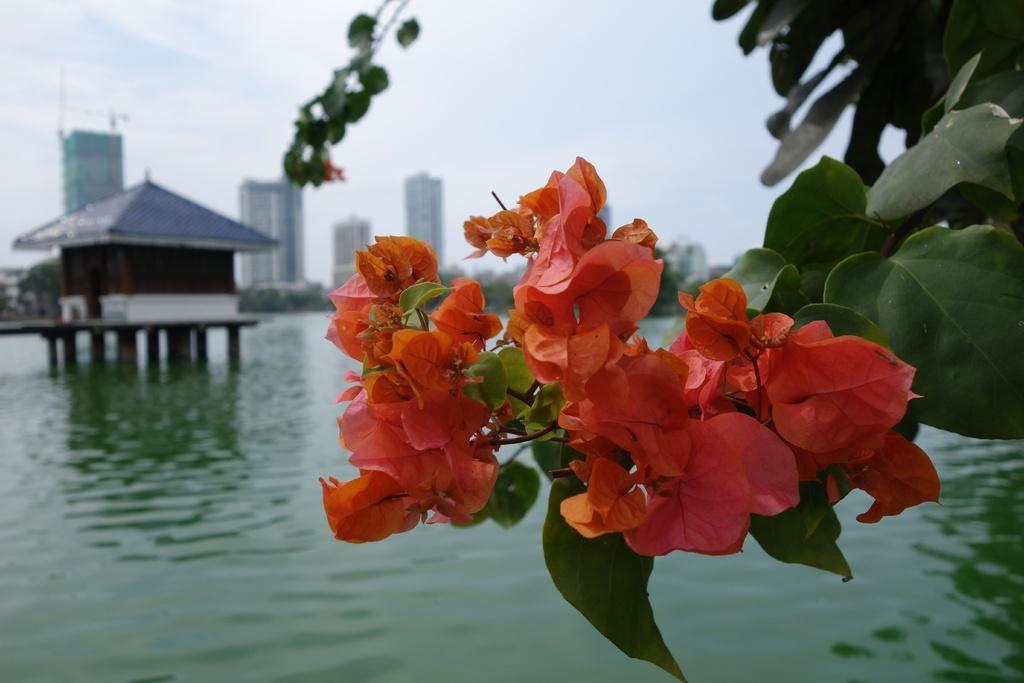What type of plants can be seen in the image? There are flowers and leaves in the image. What is the natural element visible in the image? There is water visible in the image. What type of structure is present in the image? There is a house and other buildings in the image. What type of vegetation is present in the image? There are trees in the image. What is visible in the background of the image? The sky is visible in the background of the image. What type of alarm is ringing in the image? There is no alarm present in the image. What is the wealth status of the people living in the house in the image? The wealth status of the people living in the house cannot be determined from the image. 